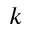<formula> <loc_0><loc_0><loc_500><loc_500>k</formula> 